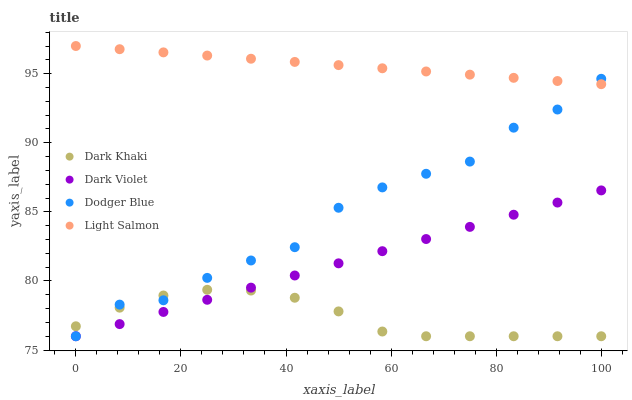Does Dark Khaki have the minimum area under the curve?
Answer yes or no. Yes. Does Light Salmon have the maximum area under the curve?
Answer yes or no. Yes. Does Dodger Blue have the minimum area under the curve?
Answer yes or no. No. Does Dodger Blue have the maximum area under the curve?
Answer yes or no. No. Is Light Salmon the smoothest?
Answer yes or no. Yes. Is Dodger Blue the roughest?
Answer yes or no. Yes. Is Dodger Blue the smoothest?
Answer yes or no. No. Is Light Salmon the roughest?
Answer yes or no. No. Does Dark Khaki have the lowest value?
Answer yes or no. Yes. Does Light Salmon have the lowest value?
Answer yes or no. No. Does Light Salmon have the highest value?
Answer yes or no. Yes. Does Dodger Blue have the highest value?
Answer yes or no. No. Is Dark Violet less than Light Salmon?
Answer yes or no. Yes. Is Light Salmon greater than Dark Violet?
Answer yes or no. Yes. Does Dodger Blue intersect Light Salmon?
Answer yes or no. Yes. Is Dodger Blue less than Light Salmon?
Answer yes or no. No. Is Dodger Blue greater than Light Salmon?
Answer yes or no. No. Does Dark Violet intersect Light Salmon?
Answer yes or no. No. 